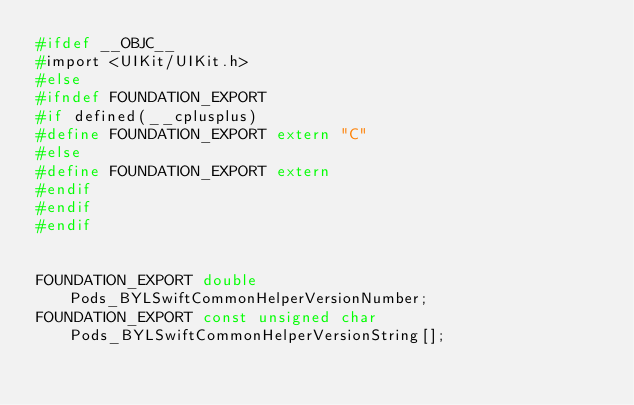Convert code to text. <code><loc_0><loc_0><loc_500><loc_500><_C_>#ifdef __OBJC__
#import <UIKit/UIKit.h>
#else
#ifndef FOUNDATION_EXPORT
#if defined(__cplusplus)
#define FOUNDATION_EXPORT extern "C"
#else
#define FOUNDATION_EXPORT extern
#endif
#endif
#endif


FOUNDATION_EXPORT double Pods_BYLSwiftCommonHelperVersionNumber;
FOUNDATION_EXPORT const unsigned char Pods_BYLSwiftCommonHelperVersionString[];

</code> 